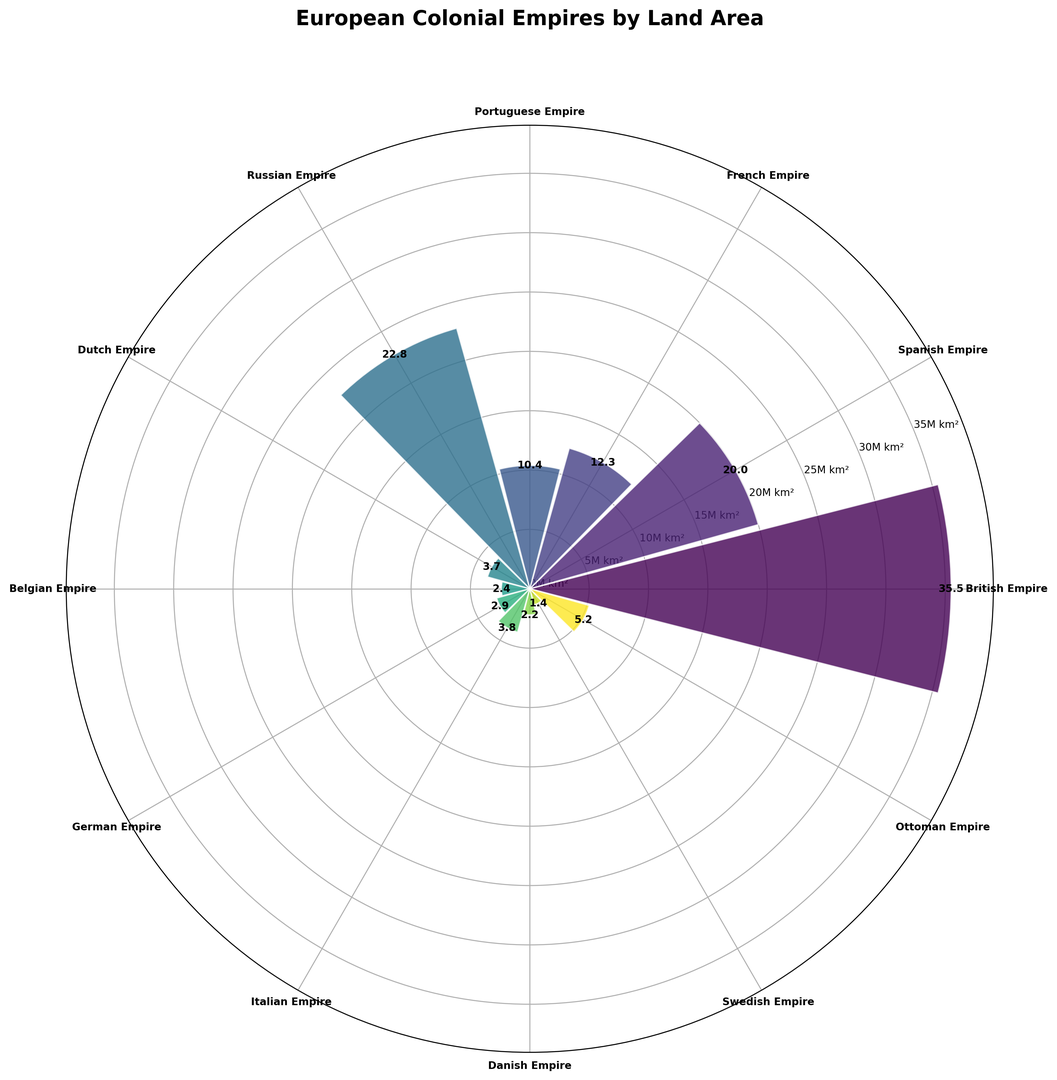What is the largest colonial empire by land area in the figure? The largest colonial empire can be identified by the height of the bar representing the land area. The tallest bar corresponds to the British Empire.
Answer: British Empire Which colonial empires controlled land areas between 10 and 15 million square kilometers? To find the empires controlling land areas within this range, look for bars with heights between 10 and 15 million square kilometers on the radial axis. The French Empire and Portuguese Empire fall within this range.
Answer: French Empire, Portuguese Empire Is the land area controlled by the German Empire greater than that of the Dutch Empire? To compare the land areas, observe the heights of the bars corresponding to the German Empire and Dutch Empire. The height of the German Empire's bar is greater than that of the Dutch Empire.
Answer: Yes What is the total land area controlled by the Spanish and Russian Empires? Sum the land areas of the Spanish Empire (20.0 million sq km) and the Russian Empire (22.8 million sq km) for the total land area. 20.0 + 22.8 = 42.8 million sq km.
Answer: 42.8 million sq km Which two empires have nearly identical land areas, and what are those areas? Look for bars that have similar heights. The Italian Empire and Dutch Empire have nearly identical land areas, each controlling around 3.7 - 3.8 million square kilometers.
Answer: Italian Empire, Dutch Empire; around 3.7 - 3.8 million sq km What is the average land area controlled by the British, French, and Spanish Empires? Sum the land areas of the British Empire (35.5), French Empire (12.3), and Spanish Empire (20.0). The total is 67.8. Divide by 3 to find the average. 67.8 / 3 = 22.6 million sq km.
Answer: 22.6 million sq km How does the land area controlled by the Belgian Empire compare to that of the Danish Empire? Compare the heights of the bars for the Belgian Empire and the Danish Empire. The Belgian Empire's bar height is slightly greater than that of the Danish Empire.
Answer: Greater What is the total land area controlled by the colonial empires shown in the figure? Sum the land areas of all the empires: 35.5 + 20.0 + 12.3 + 10.4 + 22.8 + 3.7 + 2.4 + 2.9 + 3.8 + 2.2 + 1.4 + 5.2 = 122.6 million sq km.
Answer: 122.6 million sq km Which empire controlled the smallest land area, and what was that area? Identify the shortest bar in the figure, which corresponds to the Swedish Empire with a land area of 1.4 million square kilometers.
Answer: Swedish Empire, 1.4 million sq km 